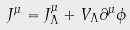<formula> <loc_0><loc_0><loc_500><loc_500>J ^ { \mu } = J _ { \Lambda } ^ { \mu } + V _ { \Lambda } \partial ^ { \mu } \phi</formula> 